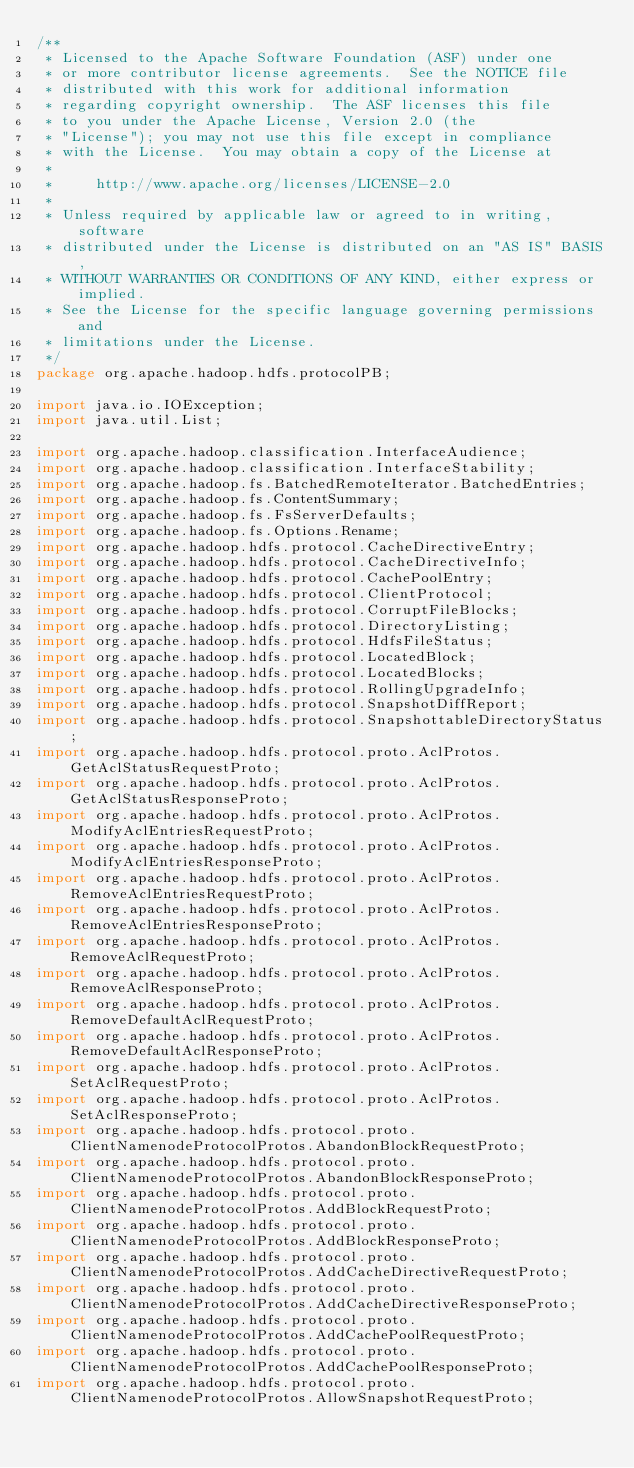<code> <loc_0><loc_0><loc_500><loc_500><_Java_>/**
 * Licensed to the Apache Software Foundation (ASF) under one
 * or more contributor license agreements.  See the NOTICE file
 * distributed with this work for additional information
 * regarding copyright ownership.  The ASF licenses this file
 * to you under the Apache License, Version 2.0 (the
 * "License"); you may not use this file except in compliance
 * with the License.  You may obtain a copy of the License at
 *
 *     http://www.apache.org/licenses/LICENSE-2.0
 *
 * Unless required by applicable law or agreed to in writing, software
 * distributed under the License is distributed on an "AS IS" BASIS,
 * WITHOUT WARRANTIES OR CONDITIONS OF ANY KIND, either express or implied.
 * See the License for the specific language governing permissions and
 * limitations under the License.
 */
package org.apache.hadoop.hdfs.protocolPB;

import java.io.IOException;
import java.util.List;

import org.apache.hadoop.classification.InterfaceAudience;
import org.apache.hadoop.classification.InterfaceStability;
import org.apache.hadoop.fs.BatchedRemoteIterator.BatchedEntries;
import org.apache.hadoop.fs.ContentSummary;
import org.apache.hadoop.fs.FsServerDefaults;
import org.apache.hadoop.fs.Options.Rename;
import org.apache.hadoop.hdfs.protocol.CacheDirectiveEntry;
import org.apache.hadoop.hdfs.protocol.CacheDirectiveInfo;
import org.apache.hadoop.hdfs.protocol.CachePoolEntry;
import org.apache.hadoop.hdfs.protocol.ClientProtocol;
import org.apache.hadoop.hdfs.protocol.CorruptFileBlocks;
import org.apache.hadoop.hdfs.protocol.DirectoryListing;
import org.apache.hadoop.hdfs.protocol.HdfsFileStatus;
import org.apache.hadoop.hdfs.protocol.LocatedBlock;
import org.apache.hadoop.hdfs.protocol.LocatedBlocks;
import org.apache.hadoop.hdfs.protocol.RollingUpgradeInfo;
import org.apache.hadoop.hdfs.protocol.SnapshotDiffReport;
import org.apache.hadoop.hdfs.protocol.SnapshottableDirectoryStatus;
import org.apache.hadoop.hdfs.protocol.proto.AclProtos.GetAclStatusRequestProto;
import org.apache.hadoop.hdfs.protocol.proto.AclProtos.GetAclStatusResponseProto;
import org.apache.hadoop.hdfs.protocol.proto.AclProtos.ModifyAclEntriesRequestProto;
import org.apache.hadoop.hdfs.protocol.proto.AclProtos.ModifyAclEntriesResponseProto;
import org.apache.hadoop.hdfs.protocol.proto.AclProtos.RemoveAclEntriesRequestProto;
import org.apache.hadoop.hdfs.protocol.proto.AclProtos.RemoveAclEntriesResponseProto;
import org.apache.hadoop.hdfs.protocol.proto.AclProtos.RemoveAclRequestProto;
import org.apache.hadoop.hdfs.protocol.proto.AclProtos.RemoveAclResponseProto;
import org.apache.hadoop.hdfs.protocol.proto.AclProtos.RemoveDefaultAclRequestProto;
import org.apache.hadoop.hdfs.protocol.proto.AclProtos.RemoveDefaultAclResponseProto;
import org.apache.hadoop.hdfs.protocol.proto.AclProtos.SetAclRequestProto;
import org.apache.hadoop.hdfs.protocol.proto.AclProtos.SetAclResponseProto;
import org.apache.hadoop.hdfs.protocol.proto.ClientNamenodeProtocolProtos.AbandonBlockRequestProto;
import org.apache.hadoop.hdfs.protocol.proto.ClientNamenodeProtocolProtos.AbandonBlockResponseProto;
import org.apache.hadoop.hdfs.protocol.proto.ClientNamenodeProtocolProtos.AddBlockRequestProto;
import org.apache.hadoop.hdfs.protocol.proto.ClientNamenodeProtocolProtos.AddBlockResponseProto;
import org.apache.hadoop.hdfs.protocol.proto.ClientNamenodeProtocolProtos.AddCacheDirectiveRequestProto;
import org.apache.hadoop.hdfs.protocol.proto.ClientNamenodeProtocolProtos.AddCacheDirectiveResponseProto;
import org.apache.hadoop.hdfs.protocol.proto.ClientNamenodeProtocolProtos.AddCachePoolRequestProto;
import org.apache.hadoop.hdfs.protocol.proto.ClientNamenodeProtocolProtos.AddCachePoolResponseProto;
import org.apache.hadoop.hdfs.protocol.proto.ClientNamenodeProtocolProtos.AllowSnapshotRequestProto;</code> 